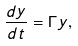Convert formula to latex. <formula><loc_0><loc_0><loc_500><loc_500>\frac { d y } { d t } = \Gamma y ,</formula> 